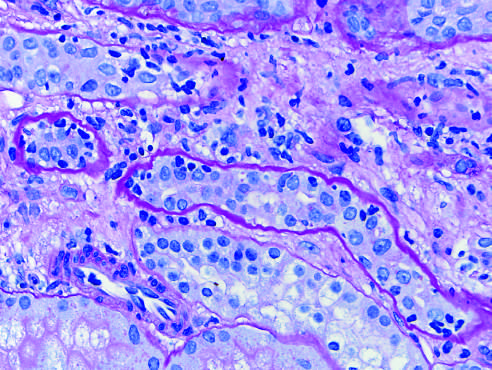re collapsed tubules outlined by wavy basement membranes?
Answer the question using a single word or phrase. Yes 